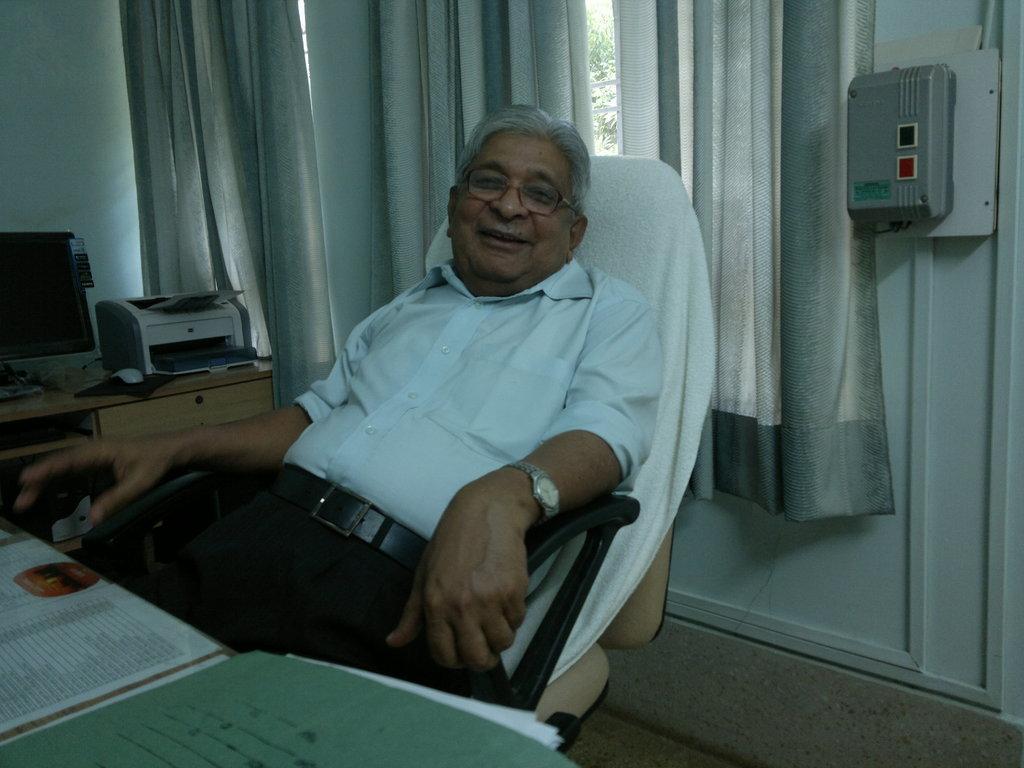How would you summarize this image in a sentence or two? In the image there is a man sitting in a chair and in front of him there is a file, some papers, a computer and printer. Behind him there are windows and in front of the windows there are curtains. 